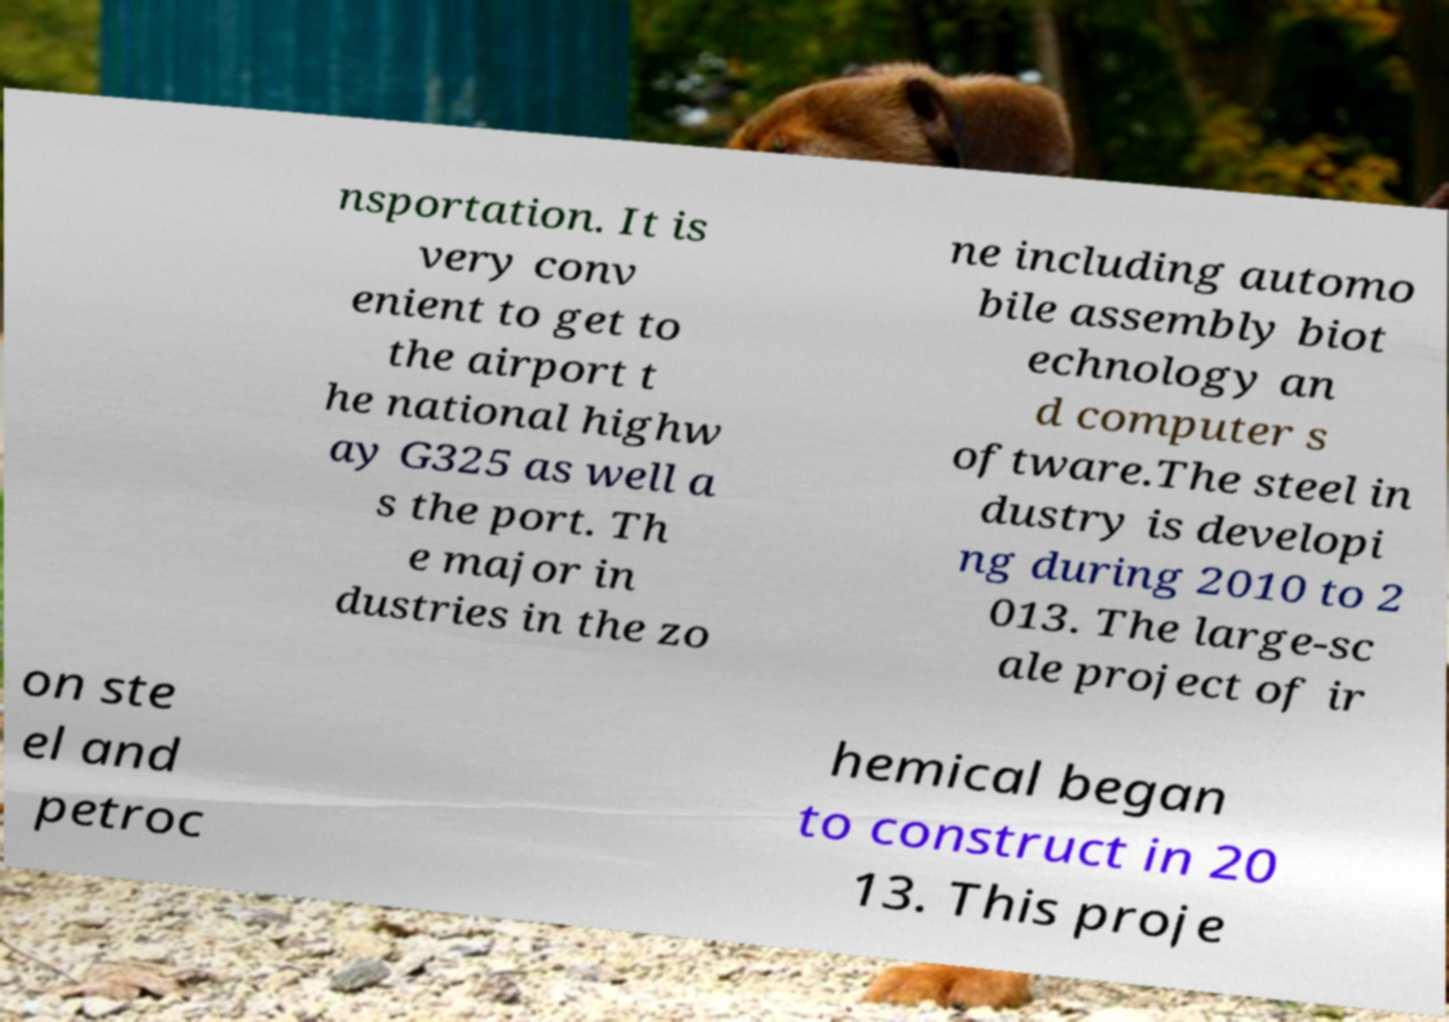What messages or text are displayed in this image? I need them in a readable, typed format. nsportation. It is very conv enient to get to the airport t he national highw ay G325 as well a s the port. Th e major in dustries in the zo ne including automo bile assembly biot echnology an d computer s oftware.The steel in dustry is developi ng during 2010 to 2 013. The large-sc ale project of ir on ste el and petroc hemical began to construct in 20 13. This proje 